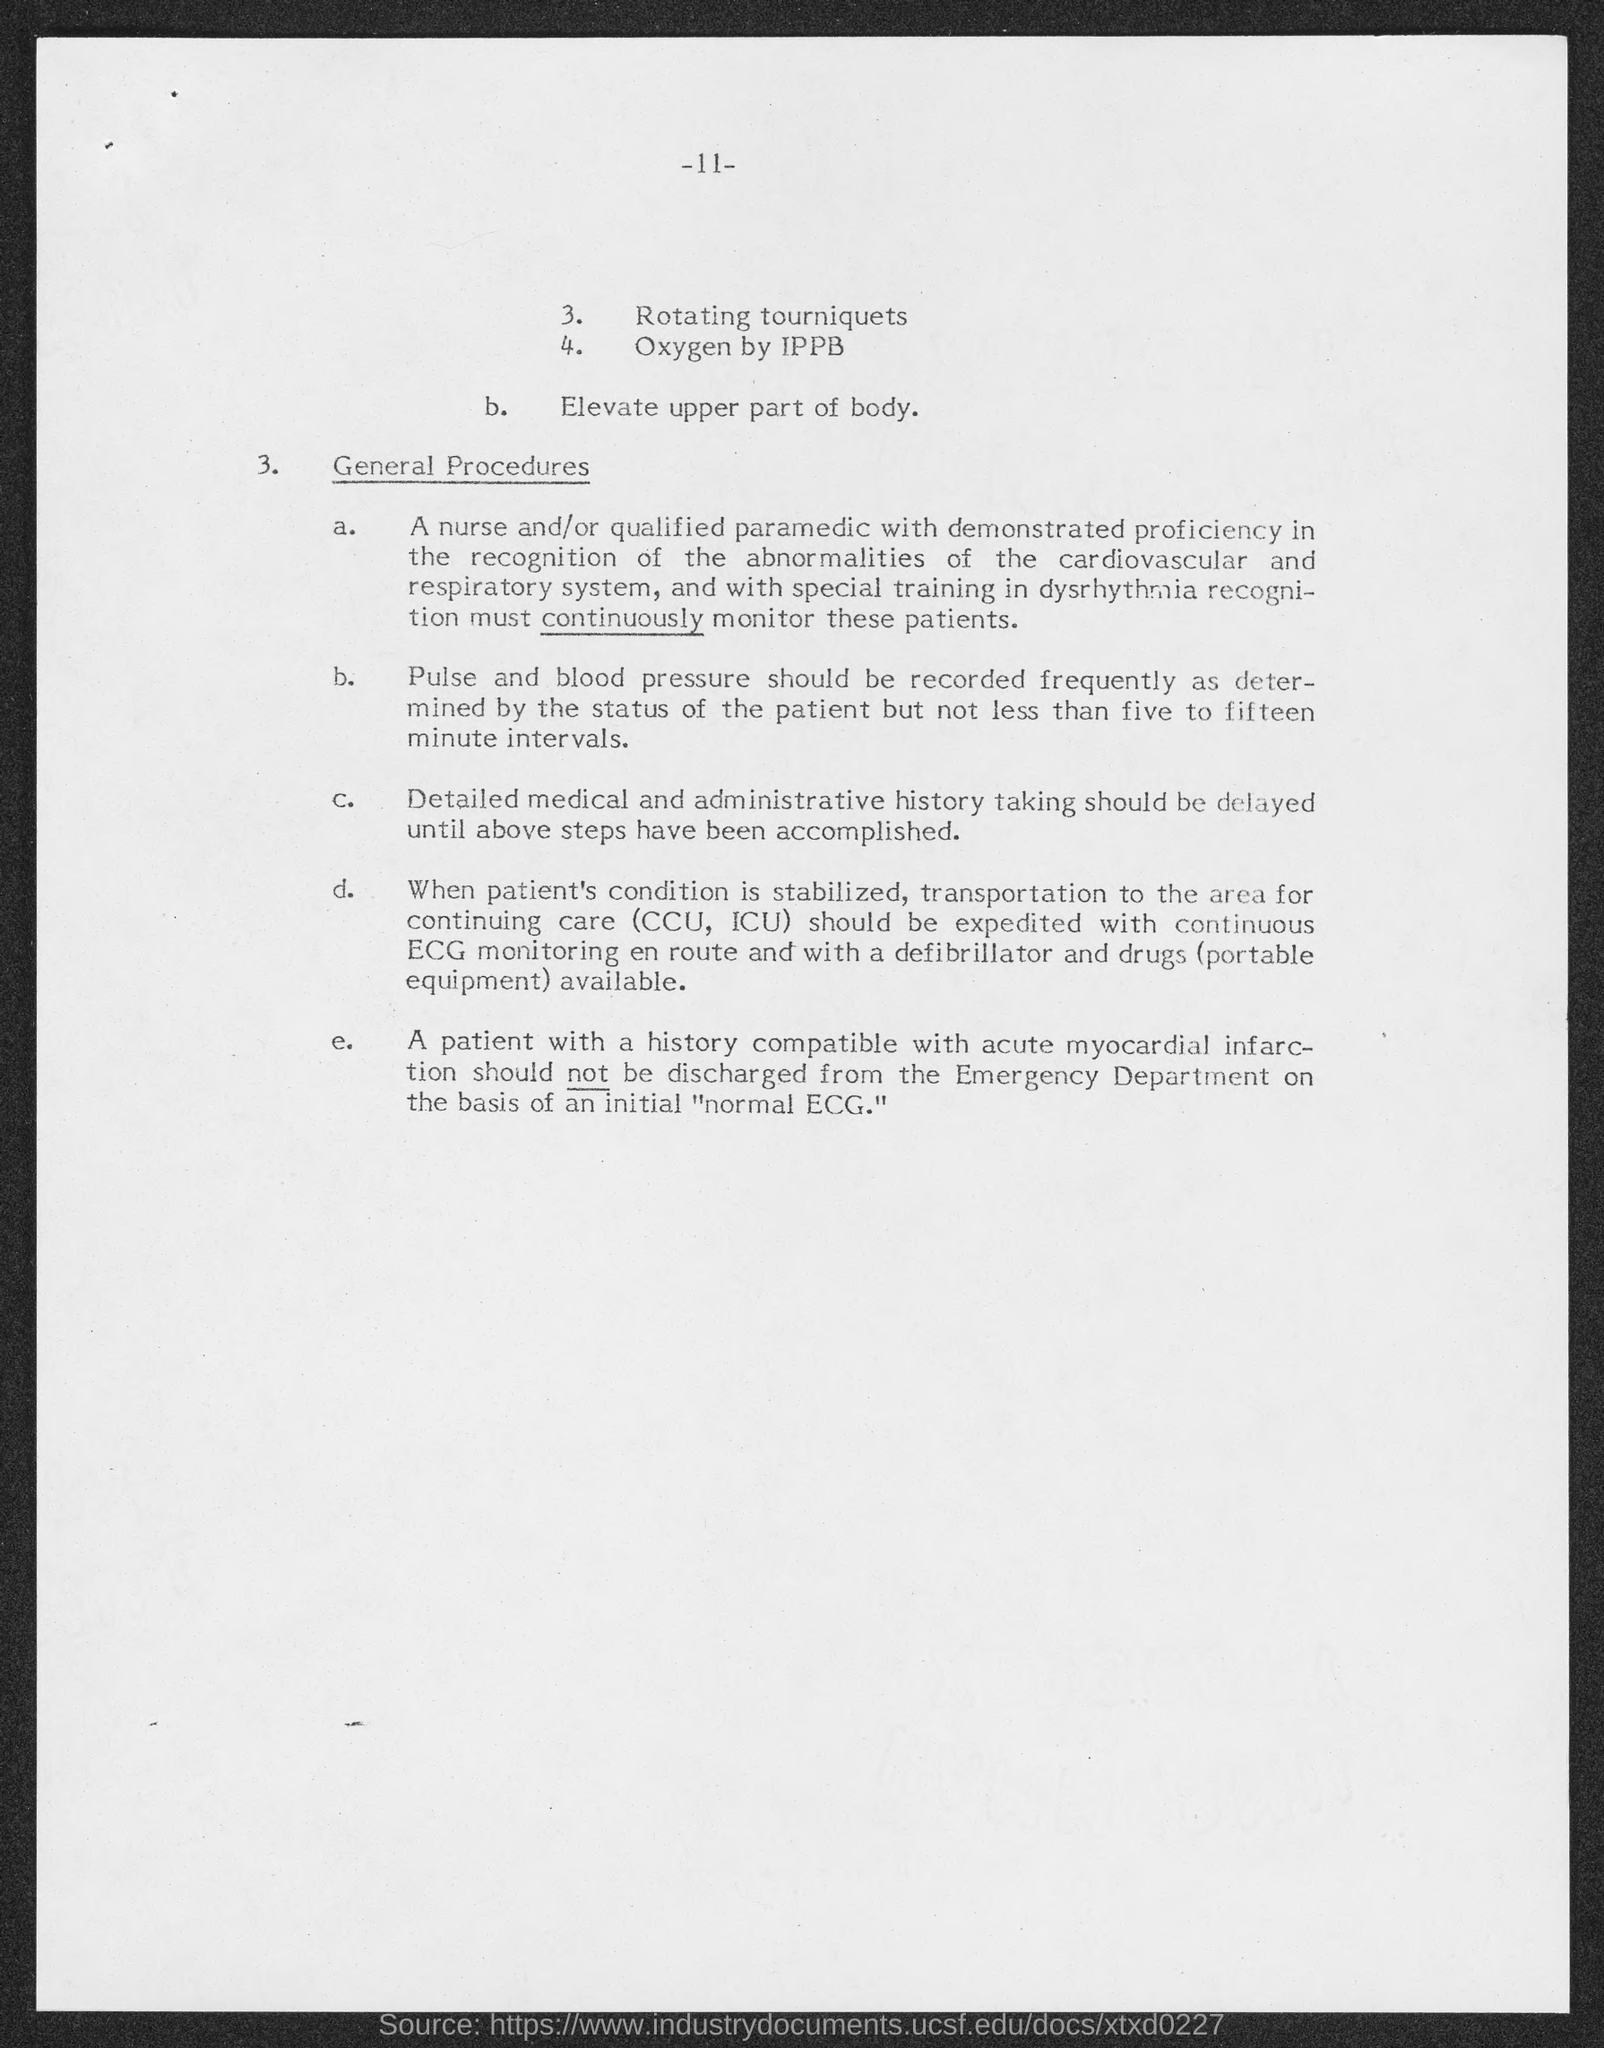Indicate a few pertinent items in this graphic. The page number at the top of the page is 11. 